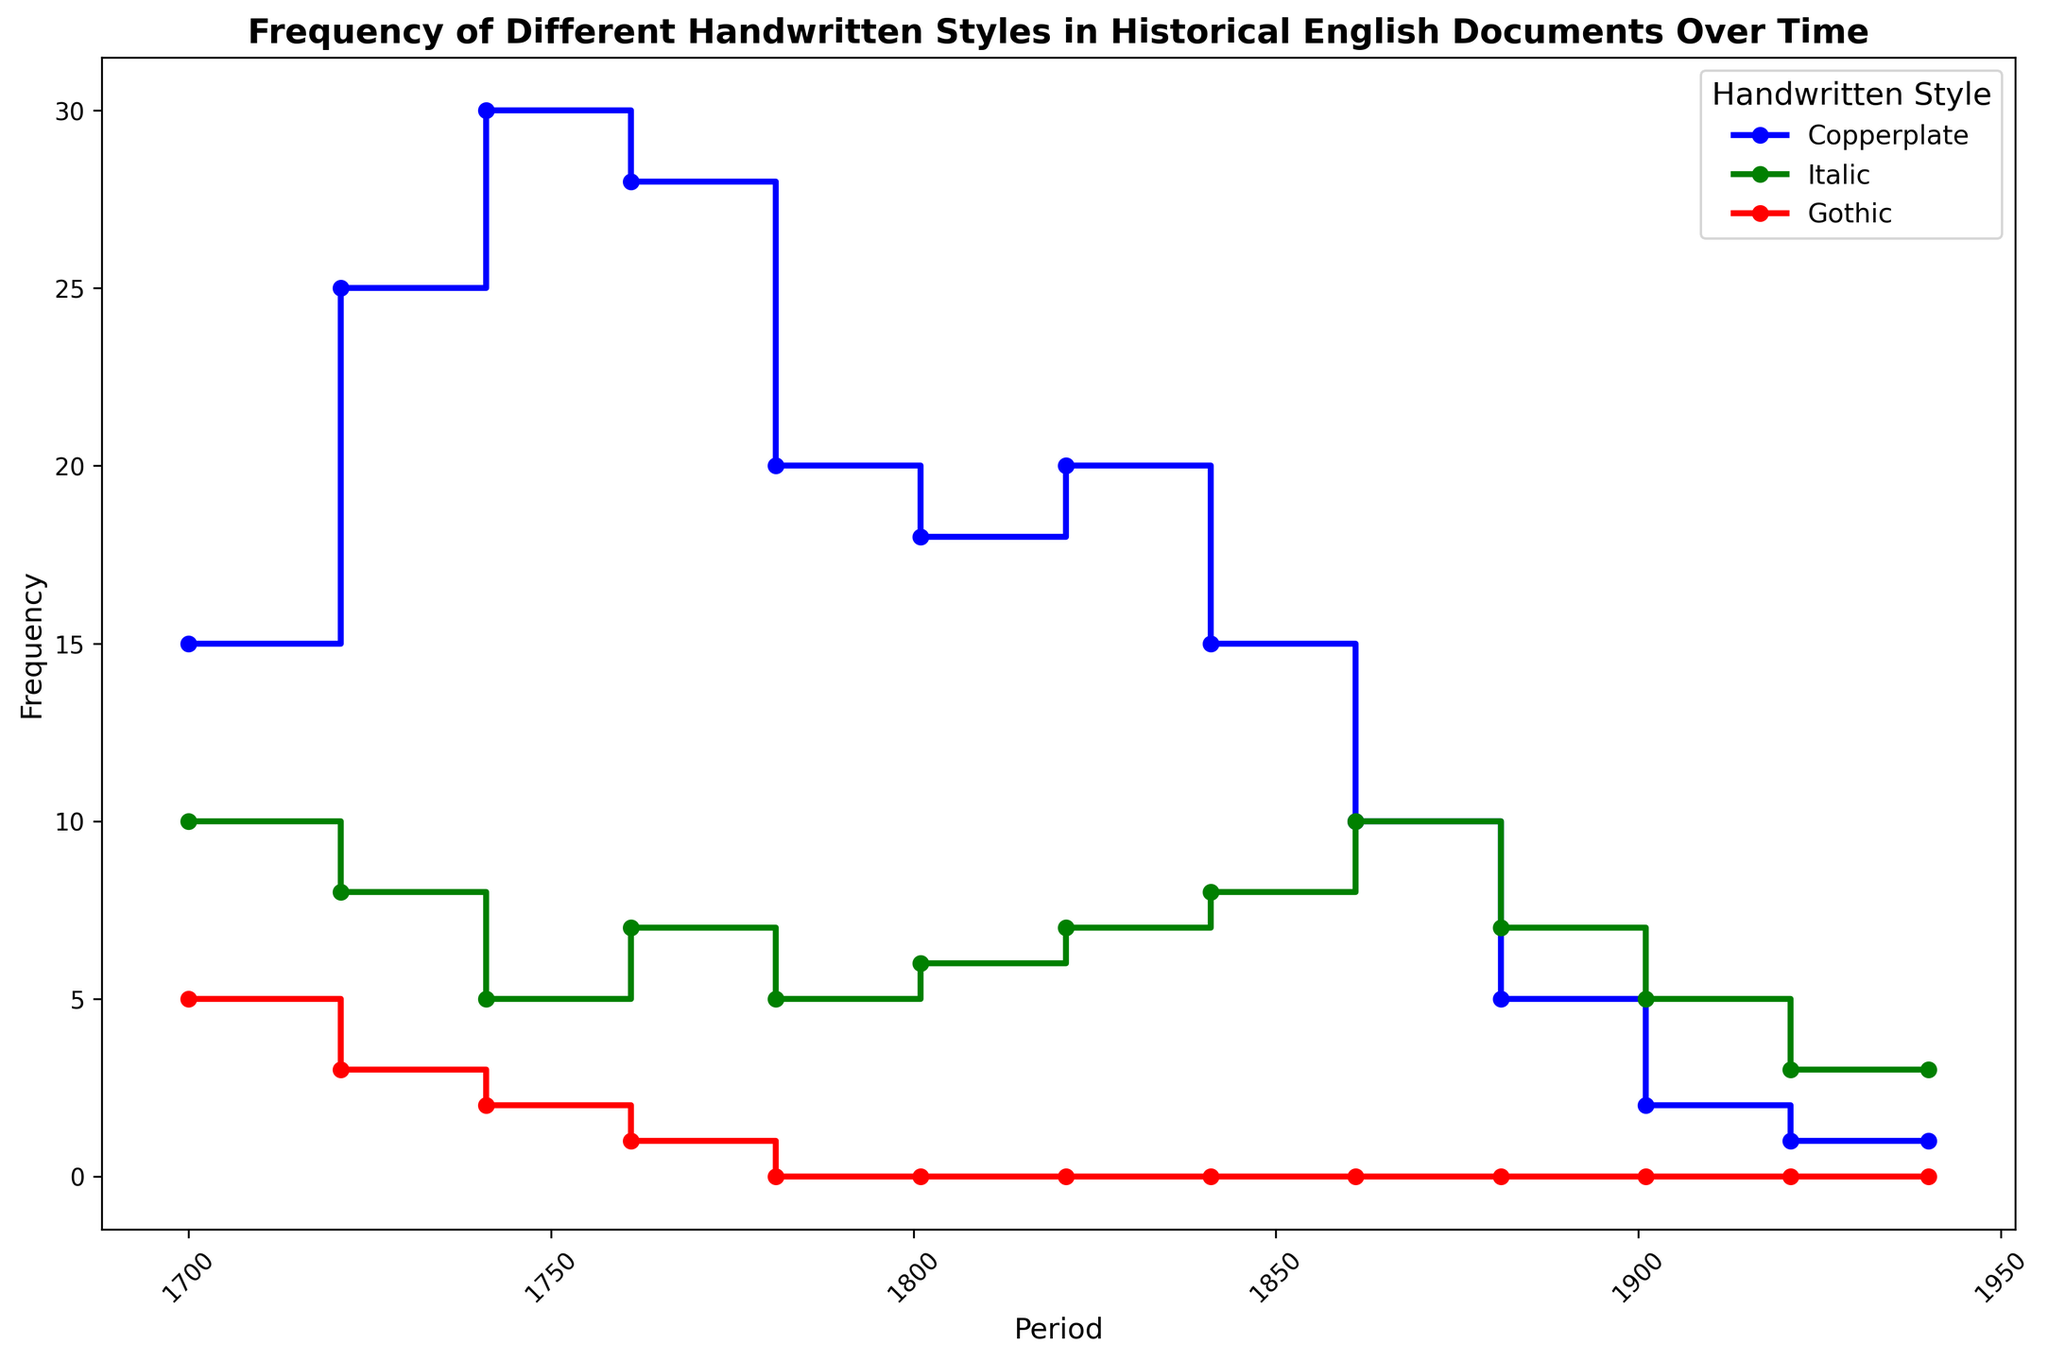What is the most frequent handwritten style in the period 1721-1740? By looking at the figure during the period 1721-1740, we see the highest point for each style. Copperplate reaches the highest frequency among the three styles.
Answer: Copperplate How does the frequency of Copperplate style in 1801-1820 compare to its frequency in 1841-1860? Compare the height of the steps in the respective periods for Copperplate. In 1801-1820, the frequency is 18, and in 1841-1860, it is 15, meaning the frequency decreased.
Answer: Decreased What is the total frequency of the Italic style from 1761-1800? Add the frequencies of Italic style for the periods 1761-1780 and 1781-1800 (7 + 5).
Answer: 12 In which period did the Gothic style disappear completely from the documents? By observing the figure, notice that the Gothic style has a frequency of 0 starting from the period 1781-1800.
Answer: 1781-1800 Between which two consecutive periods did the Copperplate style experience the largest decrease in frequency? Compare the differences in frequencies of Copperplate between consecutive periods. The largest drop is from 1861-1880 (10) to 1881-1900 (5), i.e., a decrease of 5.
Answer: 1861-1880 to 1881-1900 Which style maintained a consistent frequency from 1781-1920? Observation shows that Gothic style consistently shows a frequency of 0 from 1781 till 1920.
Answer: Gothic What is the approximate average frequency of Copperplate style across all periods? Add all frequencies for Copperplate and divide by the number of periods (15+25+30+28+20+18+20+15+10+5+2+1)/12 = 17.
Answer: 17 How did the frequency of Italic style change from 1861-1880 to 1921-1940? The figure shows a decrease in the frequency of Italic: 1861-1880 (10), and 1921-1940 (3).
Answer: Decreased Which period saw the most usage of the Copperplate style? In the figure, the highest frequency for Copperplate is 30 during the period 1741-1760.
Answer: 1741-1760 What is the ratio of the frequency of Italic style to Gothic style in 1700-1720? Italic frequency is 10 and Gothic frequency is 5 during 1700-1720. The ratio is 10/5 = 2.
Answer: 2 